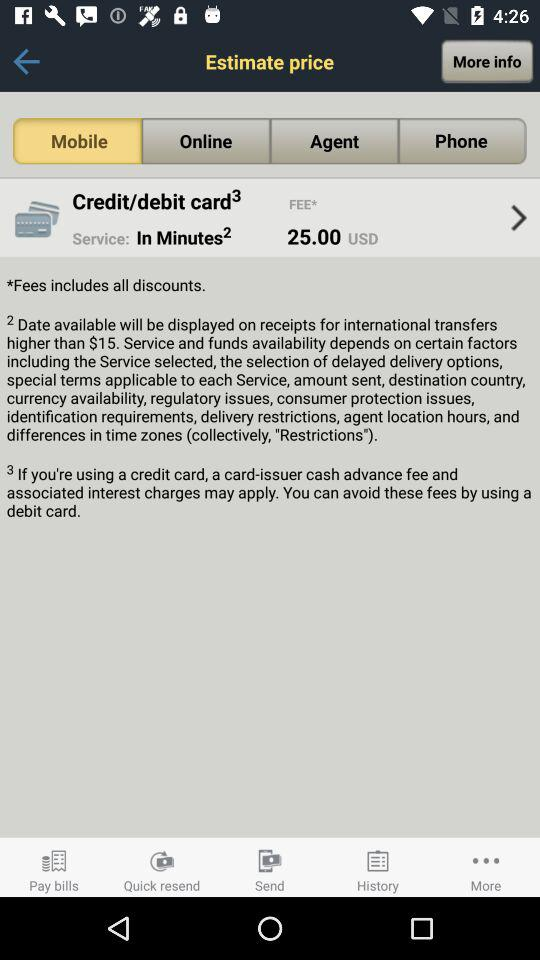What is the status of the service?
When the provided information is insufficient, respond with <no answer>. <no answer> 